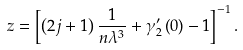<formula> <loc_0><loc_0><loc_500><loc_500>z = \left [ \left ( 2 j + 1 \right ) \frac { 1 } { n \lambda ^ { 3 } } + \gamma _ { 2 } ^ { \prime } \left ( 0 \right ) - 1 \right ] ^ { - 1 } .</formula> 